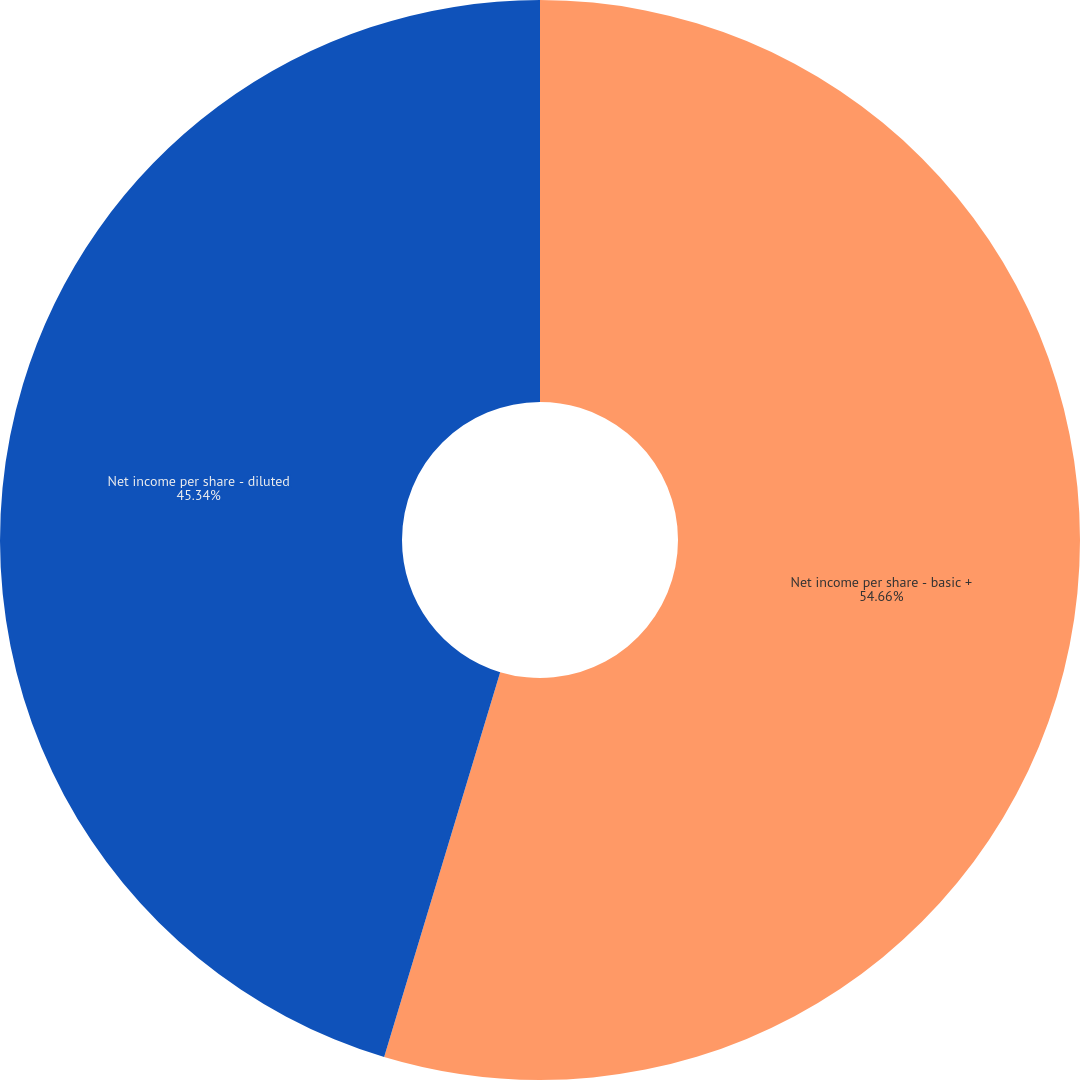Convert chart to OTSL. <chart><loc_0><loc_0><loc_500><loc_500><pie_chart><fcel>Net income per share - basic +<fcel>Net income per share - diluted<nl><fcel>54.66%<fcel>45.34%<nl></chart> 